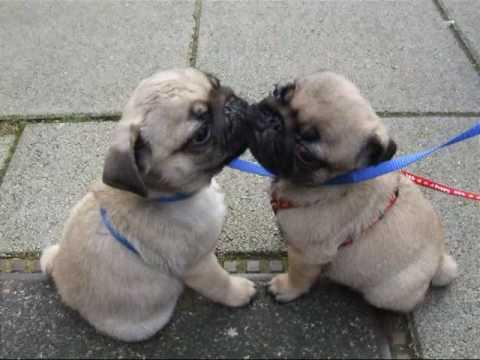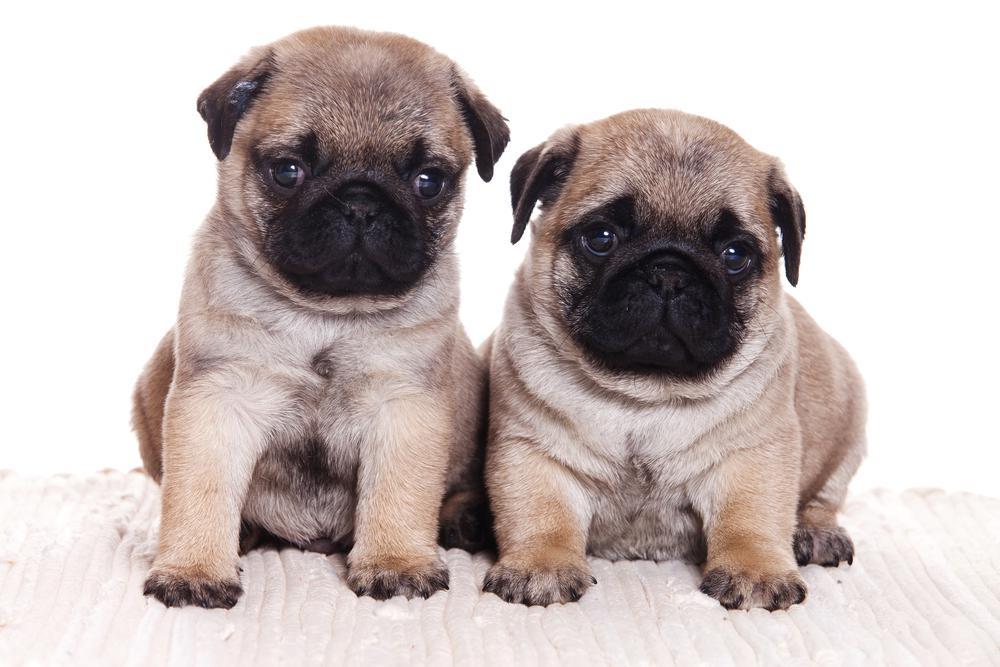The first image is the image on the left, the second image is the image on the right. For the images displayed, is the sentence "One pair of dogs is sitting in front of some flowers." factually correct? Answer yes or no. No. The first image is the image on the left, the second image is the image on the right. Considering the images on both sides, is "Two nearly identical looking pug puppies lie flat on their bellies, side-by-side, with eyes closed." valid? Answer yes or no. No. 